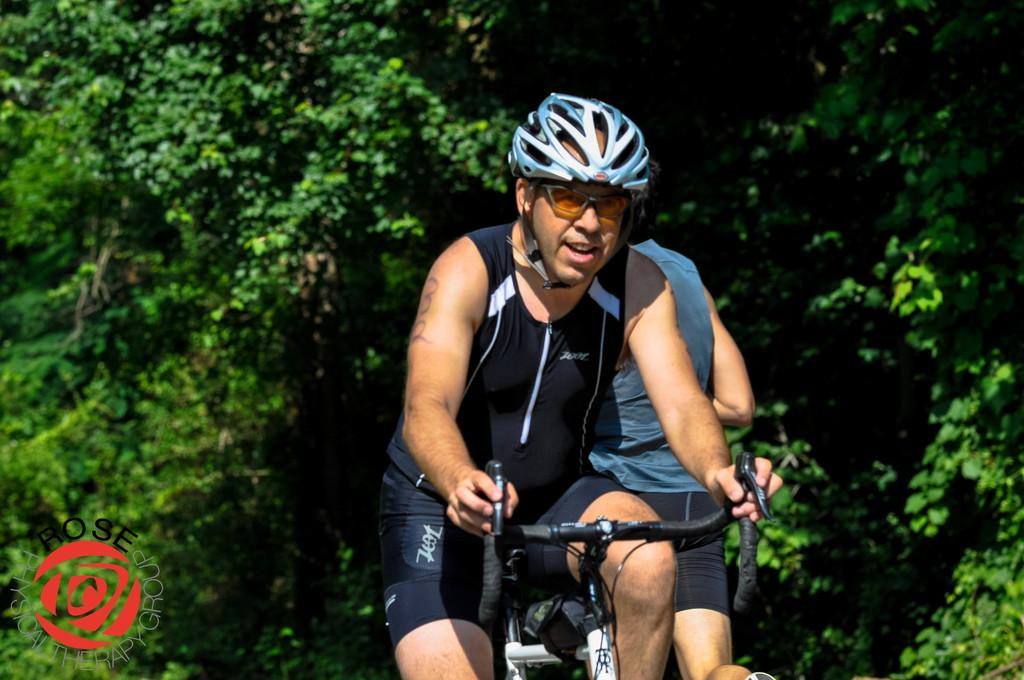What is the main subject of the image? There is a person riding a bicycle in the image. What safety precaution is the person taking while riding the bicycle? The person is wearing a helmet. Can you describe the environment in the image? There are many trees in the background of the image. Are there any other people visible in the image? Yes, there is another person visible in the image. What color is the tail of the person riding the bicycle in the image? There is no tail present on the person riding the bicycle in the image. 